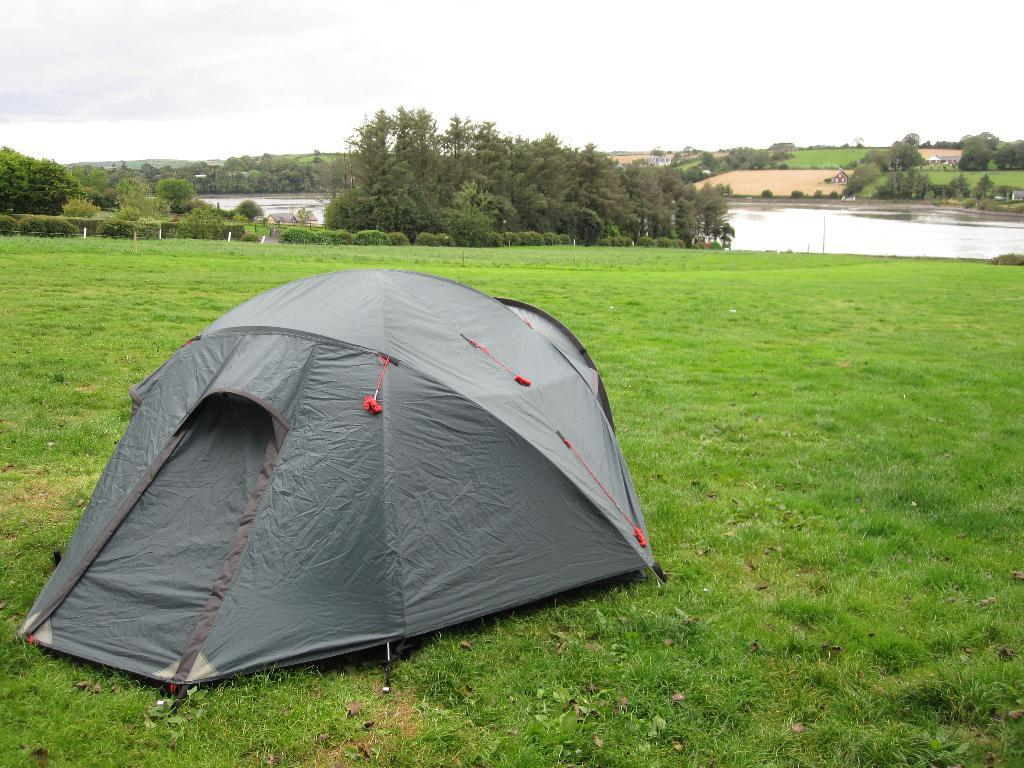What type of shelter is present in the image? There is a tent in the image. What type of ground surface is visible in the image? There is grass in the image. What can be seen in the background of the image? There are trees and water visible in the background of the image. What is visible at the top of the image? The sky is visible at the top of the image. Where is the throne located in the image? There is no throne present in the image. What is the zinc used for in the image? There is no zinc present in the image. 